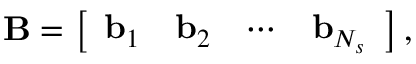Convert formula to latex. <formula><loc_0><loc_0><loc_500><loc_500>B = \left [ \begin{array} { l l l l } { b _ { 1 } } & { b _ { 2 } } & { \cdots } & { b _ { N _ { s } } } \end{array} \right ] ,</formula> 